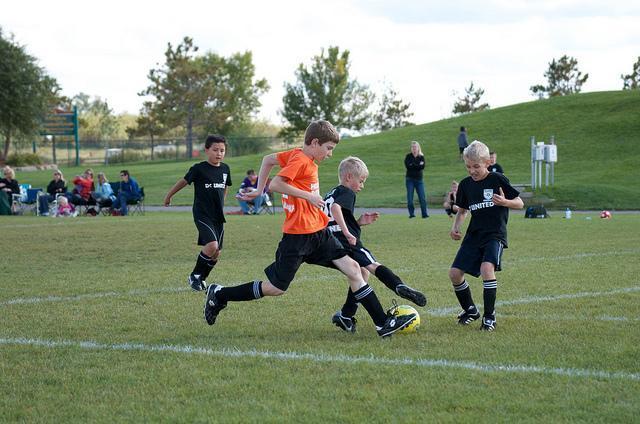How many kids are wearing orange shirts?
Give a very brief answer. 1. How many people are in the picture?
Give a very brief answer. 4. How many red cars are there?
Give a very brief answer. 0. 